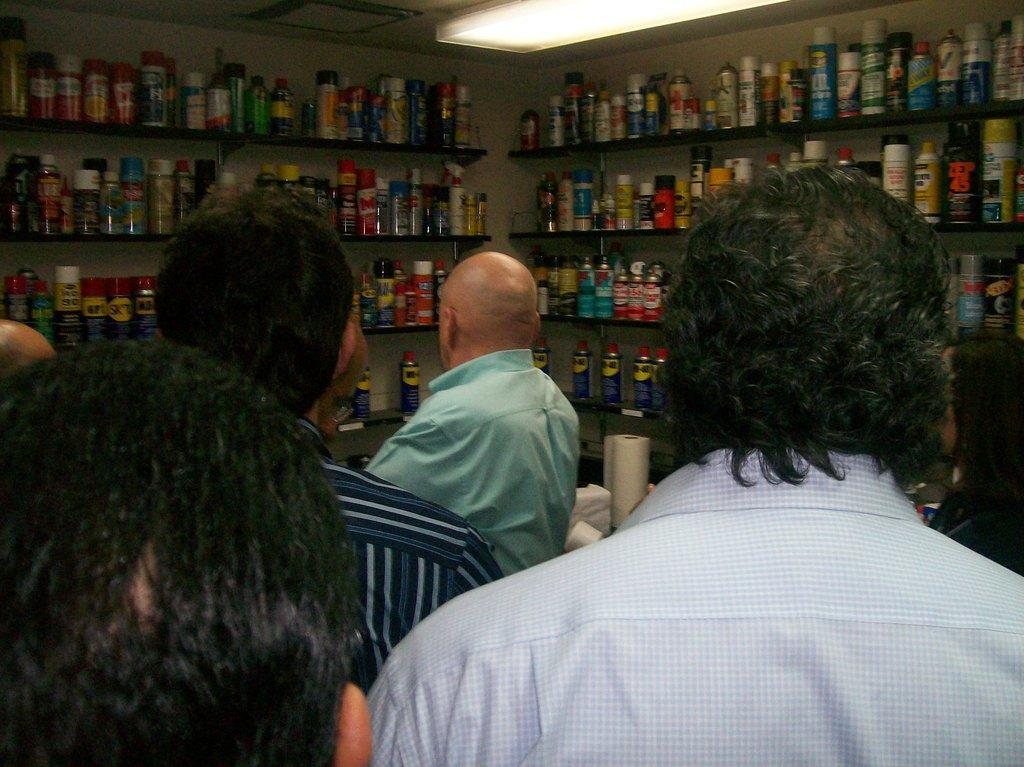Who or what can be seen in the image? There are people in the image. What can be seen in the background of the image? There are bottles arranged on a shelf in the background of the image. What is visible at the top of the image? There is a ceiling with lights visible at the top of the image. How many threads are hanging from the ceiling in the image? There are no threads hanging from the ceiling in the image; only lights are visible. 